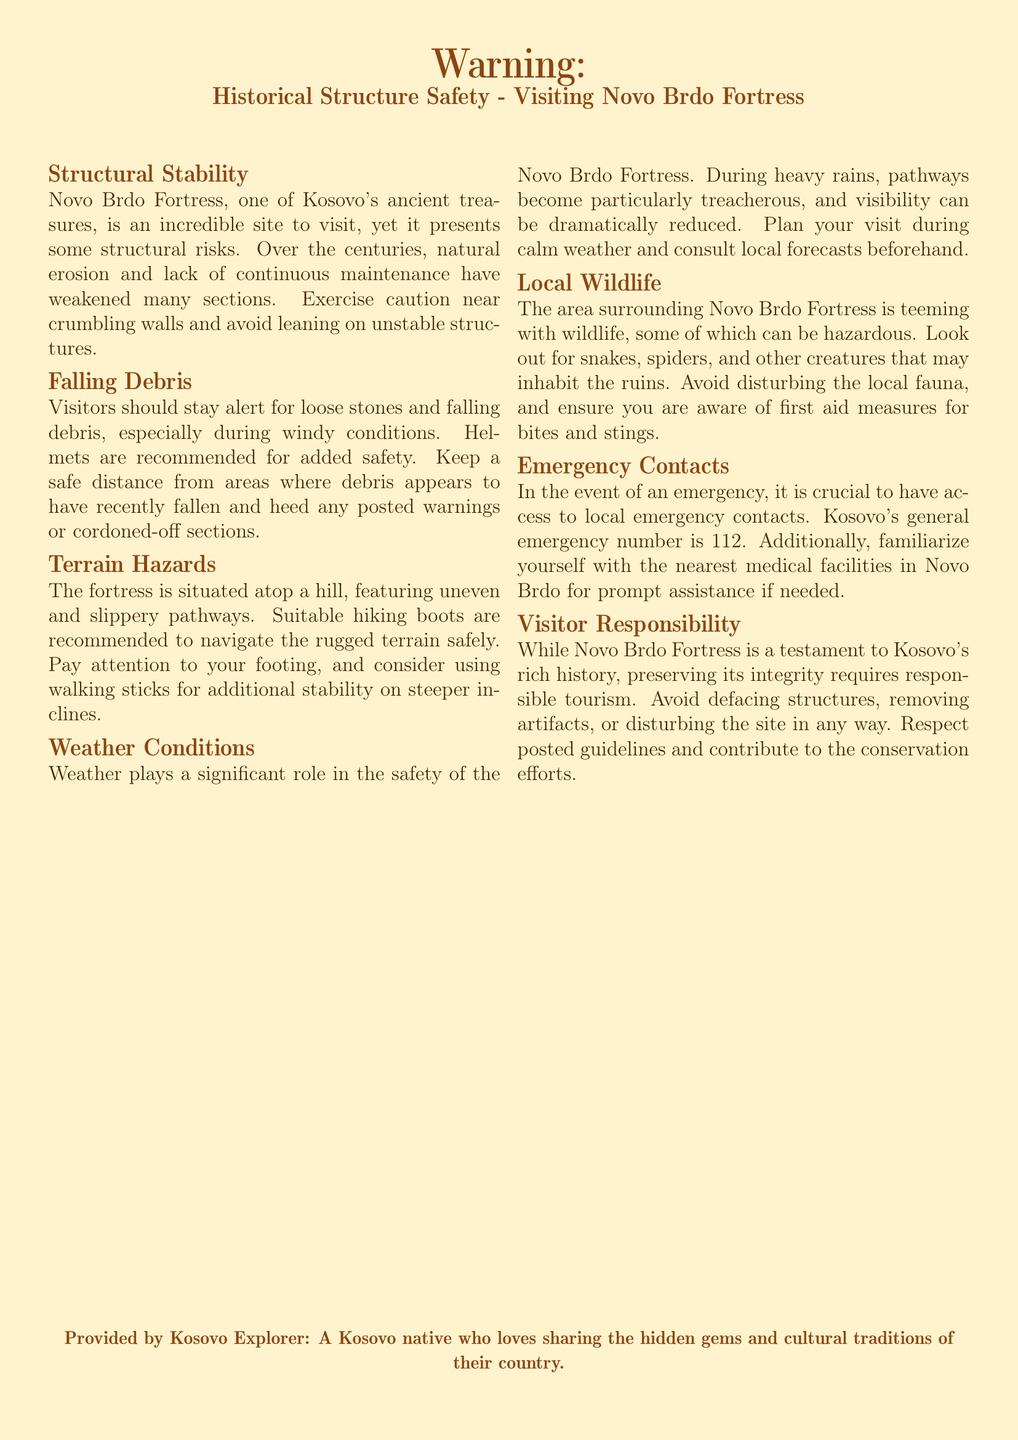What is the warning about structural risks related to? The warning discusses structural risks associated with natural erosion and lack of maintenance in Novo Brdo Fortress.
Answer: Structural stability What is recommended to wear when visiting the fortress? The document recommends wearing suitable hiking boots to navigate the rugged terrain safely.
Answer: Hiking boots What should visitors do to avoid falling debris? Visitors are advised to stay alert, wear helmets, and keep a safe distance from hazardous areas.
Answer: Wear helmets What is the general emergency number in Kosovo? The emergency number provided in the document for Kosovo is used for various emergency situations.
Answer: 112 What natural hazard is mentioned regarding the weather? The document highlights that heavy rains make pathways particularly treacherous and visibility can reduce significantly.
Answer: Treacherous pathways What should tourists respect to contribute to conservation efforts? Tourists are instructed to respect posted guidelines to help preserve the integrity of the fortress.
Answer: Posted guidelines What kind of local wildlife should visitors beware of? The warning mentions several hazardous creatures present in the area surrounding the fortress.
Answer: Snakes What is the purpose of this document? This document serves as a warning label about safety precautions for visitors to Novo Brdo Fortress.
Answer: Safety precautions What should visitors avoid doing at the fortress? The document advises against defacing structures or removing artifacts at the site.
Answer: Defacing structures 